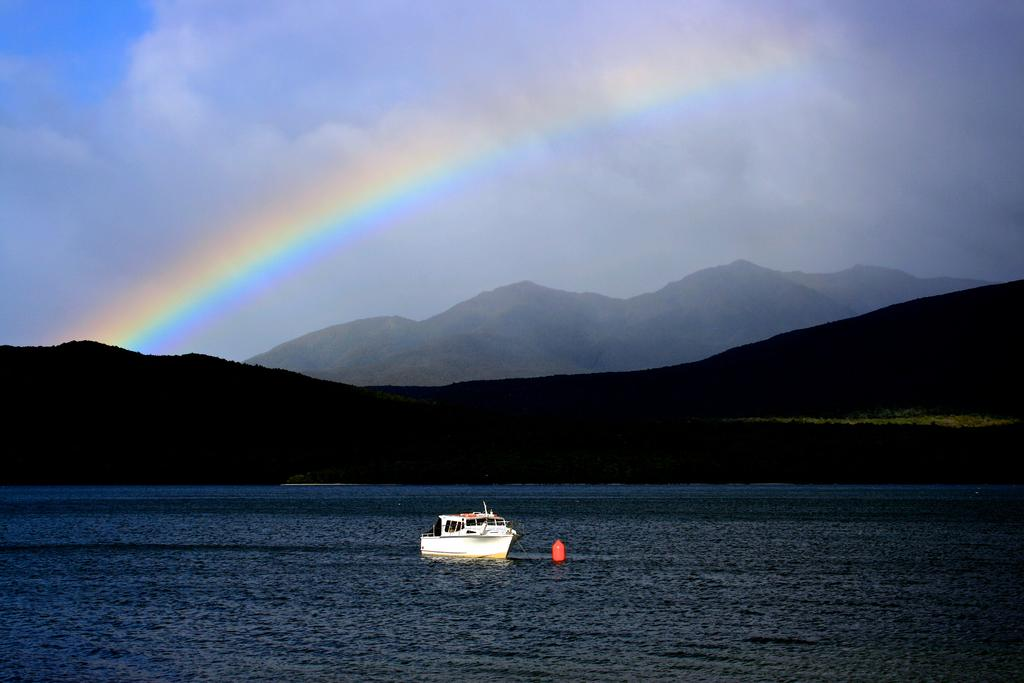What is on the surface of the water in the image? There is a boat on the surface of the water in the image. What can be seen in the background of the image? There are hills and mountains in the background of the image. What is visible in the sky in the image? The sky is visible in the background of the image, and clouds are present. What additional feature can be seen in the image? A rainbow is visible in the image. Where is the landmark in the image? There is no specific landmark mentioned in the provided facts, so it cannot be determined from the image. 